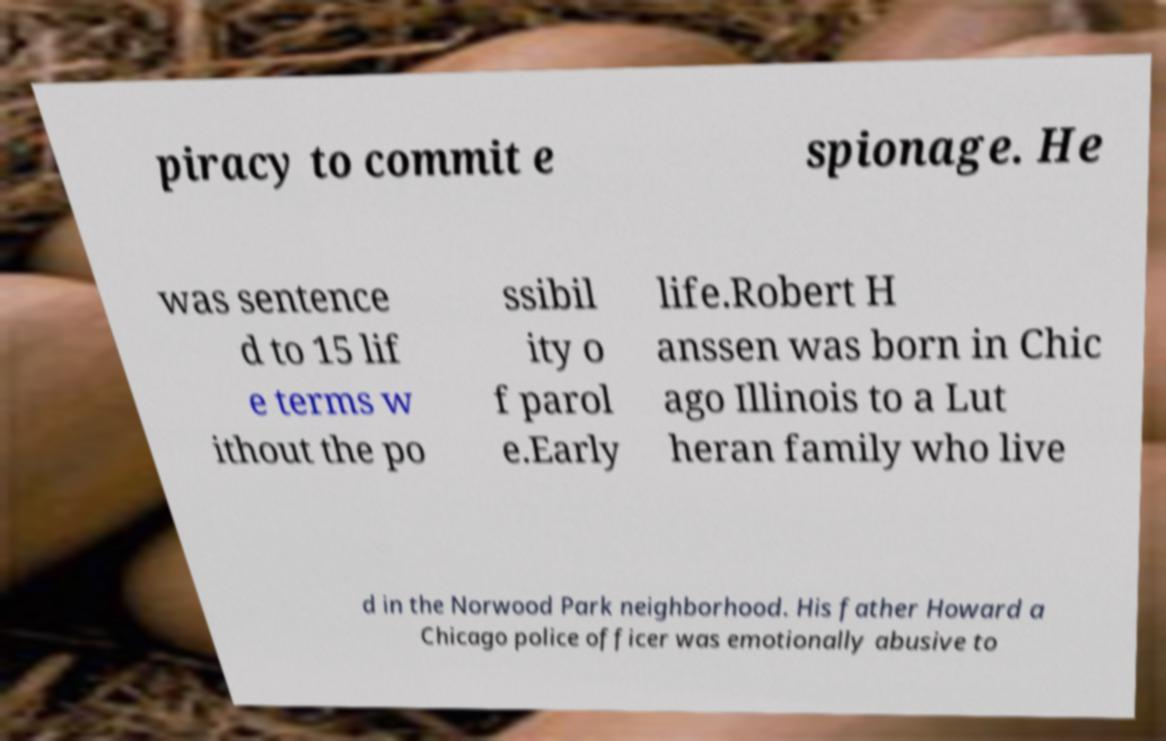Can you accurately transcribe the text from the provided image for me? piracy to commit e spionage. He was sentence d to 15 lif e terms w ithout the po ssibil ity o f parol e.Early life.Robert H anssen was born in Chic ago Illinois to a Lut heran family who live d in the Norwood Park neighborhood. His father Howard a Chicago police officer was emotionally abusive to 